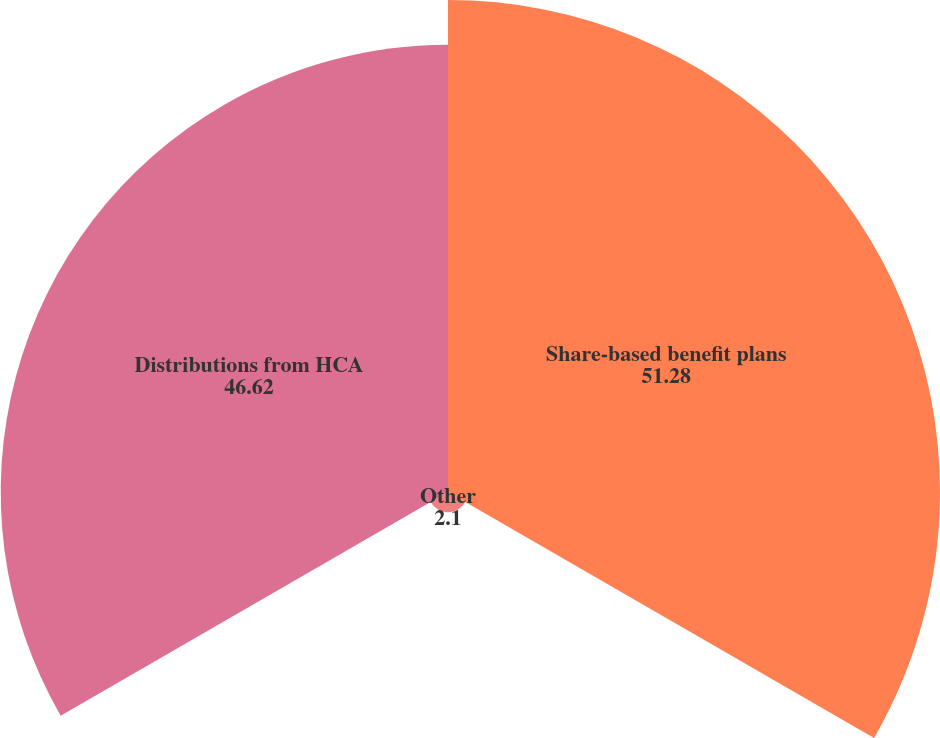Convert chart. <chart><loc_0><loc_0><loc_500><loc_500><pie_chart><fcel>Share-based benefit plans<fcel>Other<fcel>Distributions from HCA<nl><fcel>51.28%<fcel>2.1%<fcel>46.62%<nl></chart> 